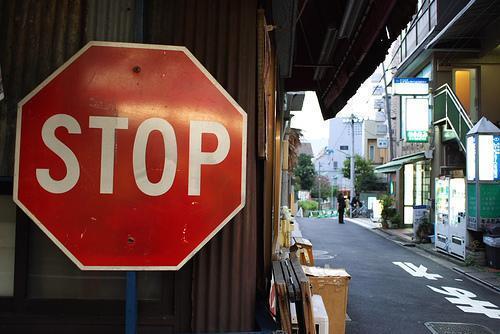How many bicycles are pictured?
Give a very brief answer. 0. 